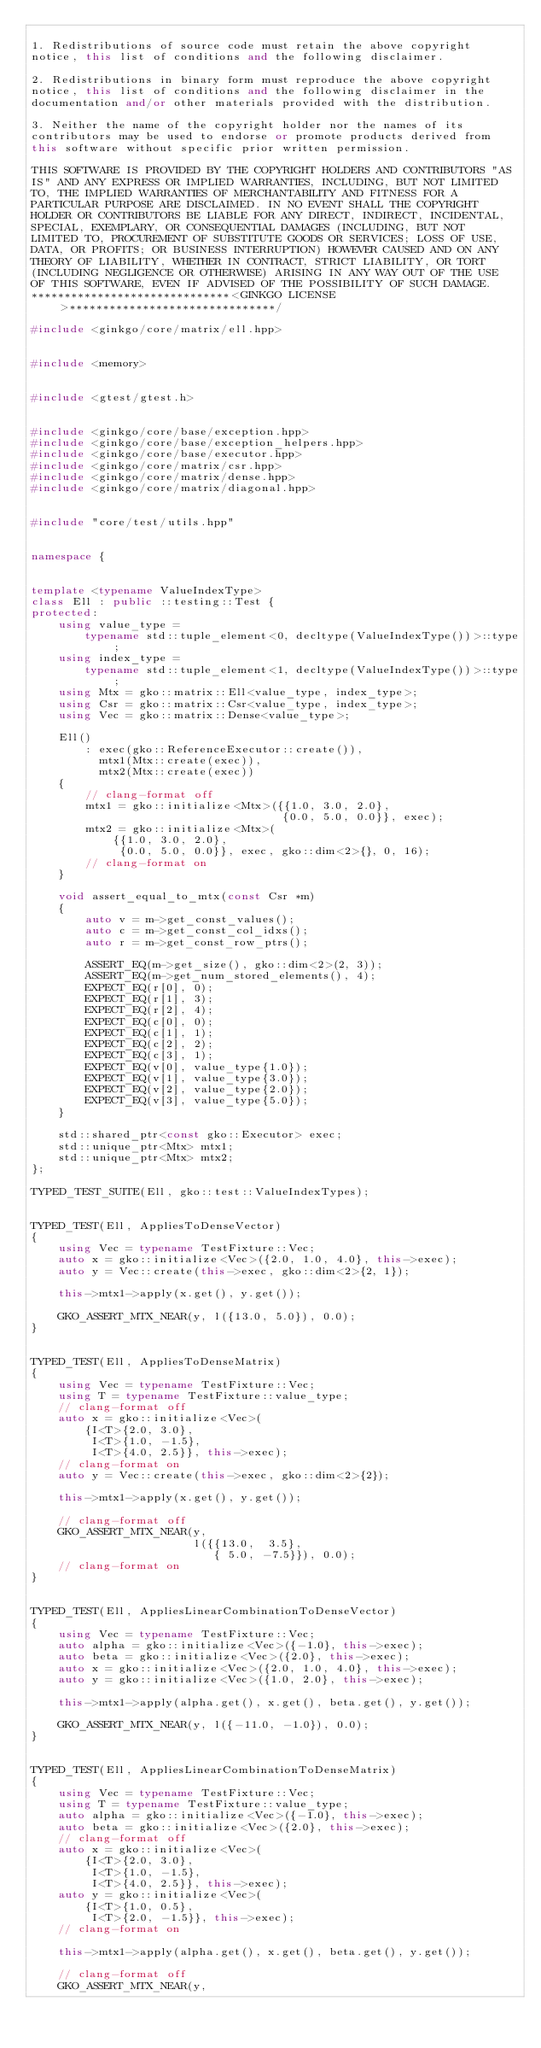<code> <loc_0><loc_0><loc_500><loc_500><_C++_>
1. Redistributions of source code must retain the above copyright
notice, this list of conditions and the following disclaimer.

2. Redistributions in binary form must reproduce the above copyright
notice, this list of conditions and the following disclaimer in the
documentation and/or other materials provided with the distribution.

3. Neither the name of the copyright holder nor the names of its
contributors may be used to endorse or promote products derived from
this software without specific prior written permission.

THIS SOFTWARE IS PROVIDED BY THE COPYRIGHT HOLDERS AND CONTRIBUTORS "AS
IS" AND ANY EXPRESS OR IMPLIED WARRANTIES, INCLUDING, BUT NOT LIMITED
TO, THE IMPLIED WARRANTIES OF MERCHANTABILITY AND FITNESS FOR A
PARTICULAR PURPOSE ARE DISCLAIMED. IN NO EVENT SHALL THE COPYRIGHT
HOLDER OR CONTRIBUTORS BE LIABLE FOR ANY DIRECT, INDIRECT, INCIDENTAL,
SPECIAL, EXEMPLARY, OR CONSEQUENTIAL DAMAGES (INCLUDING, BUT NOT
LIMITED TO, PROCUREMENT OF SUBSTITUTE GOODS OR SERVICES; LOSS OF USE,
DATA, OR PROFITS; OR BUSINESS INTERRUPTION) HOWEVER CAUSED AND ON ANY
THEORY OF LIABILITY, WHETHER IN CONTRACT, STRICT LIABILITY, OR TORT
(INCLUDING NEGLIGENCE OR OTHERWISE) ARISING IN ANY WAY OUT OF THE USE
OF THIS SOFTWARE, EVEN IF ADVISED OF THE POSSIBILITY OF SUCH DAMAGE.
******************************<GINKGO LICENSE>*******************************/

#include <ginkgo/core/matrix/ell.hpp>


#include <memory>


#include <gtest/gtest.h>


#include <ginkgo/core/base/exception.hpp>
#include <ginkgo/core/base/exception_helpers.hpp>
#include <ginkgo/core/base/executor.hpp>
#include <ginkgo/core/matrix/csr.hpp>
#include <ginkgo/core/matrix/dense.hpp>
#include <ginkgo/core/matrix/diagonal.hpp>


#include "core/test/utils.hpp"


namespace {


template <typename ValueIndexType>
class Ell : public ::testing::Test {
protected:
    using value_type =
        typename std::tuple_element<0, decltype(ValueIndexType())>::type;
    using index_type =
        typename std::tuple_element<1, decltype(ValueIndexType())>::type;
    using Mtx = gko::matrix::Ell<value_type, index_type>;
    using Csr = gko::matrix::Csr<value_type, index_type>;
    using Vec = gko::matrix::Dense<value_type>;

    Ell()
        : exec(gko::ReferenceExecutor::create()),
          mtx1(Mtx::create(exec)),
          mtx2(Mtx::create(exec))
    {
        // clang-format off
        mtx1 = gko::initialize<Mtx>({{1.0, 3.0, 2.0},
                                     {0.0, 5.0, 0.0}}, exec);
        mtx2 = gko::initialize<Mtx>(
            {{1.0, 3.0, 2.0},
             {0.0, 5.0, 0.0}}, exec, gko::dim<2>{}, 0, 16);
        // clang-format on
    }

    void assert_equal_to_mtx(const Csr *m)
    {
        auto v = m->get_const_values();
        auto c = m->get_const_col_idxs();
        auto r = m->get_const_row_ptrs();

        ASSERT_EQ(m->get_size(), gko::dim<2>(2, 3));
        ASSERT_EQ(m->get_num_stored_elements(), 4);
        EXPECT_EQ(r[0], 0);
        EXPECT_EQ(r[1], 3);
        EXPECT_EQ(r[2], 4);
        EXPECT_EQ(c[0], 0);
        EXPECT_EQ(c[1], 1);
        EXPECT_EQ(c[2], 2);
        EXPECT_EQ(c[3], 1);
        EXPECT_EQ(v[0], value_type{1.0});
        EXPECT_EQ(v[1], value_type{3.0});
        EXPECT_EQ(v[2], value_type{2.0});
        EXPECT_EQ(v[3], value_type{5.0});
    }

    std::shared_ptr<const gko::Executor> exec;
    std::unique_ptr<Mtx> mtx1;
    std::unique_ptr<Mtx> mtx2;
};

TYPED_TEST_SUITE(Ell, gko::test::ValueIndexTypes);


TYPED_TEST(Ell, AppliesToDenseVector)
{
    using Vec = typename TestFixture::Vec;
    auto x = gko::initialize<Vec>({2.0, 1.0, 4.0}, this->exec);
    auto y = Vec::create(this->exec, gko::dim<2>{2, 1});

    this->mtx1->apply(x.get(), y.get());

    GKO_ASSERT_MTX_NEAR(y, l({13.0, 5.0}), 0.0);
}


TYPED_TEST(Ell, AppliesToDenseMatrix)
{
    using Vec = typename TestFixture::Vec;
    using T = typename TestFixture::value_type;
    // clang-format off
    auto x = gko::initialize<Vec>(
        {I<T>{2.0, 3.0},
         I<T>{1.0, -1.5},
         I<T>{4.0, 2.5}}, this->exec);
    // clang-format on
    auto y = Vec::create(this->exec, gko::dim<2>{2});

    this->mtx1->apply(x.get(), y.get());

    // clang-format off
    GKO_ASSERT_MTX_NEAR(y,
                        l({{13.0,  3.5},
                           { 5.0, -7.5}}), 0.0);
    // clang-format on
}


TYPED_TEST(Ell, AppliesLinearCombinationToDenseVector)
{
    using Vec = typename TestFixture::Vec;
    auto alpha = gko::initialize<Vec>({-1.0}, this->exec);
    auto beta = gko::initialize<Vec>({2.0}, this->exec);
    auto x = gko::initialize<Vec>({2.0, 1.0, 4.0}, this->exec);
    auto y = gko::initialize<Vec>({1.0, 2.0}, this->exec);

    this->mtx1->apply(alpha.get(), x.get(), beta.get(), y.get());

    GKO_ASSERT_MTX_NEAR(y, l({-11.0, -1.0}), 0.0);
}


TYPED_TEST(Ell, AppliesLinearCombinationToDenseMatrix)
{
    using Vec = typename TestFixture::Vec;
    using T = typename TestFixture::value_type;
    auto alpha = gko::initialize<Vec>({-1.0}, this->exec);
    auto beta = gko::initialize<Vec>({2.0}, this->exec);
    // clang-format off
    auto x = gko::initialize<Vec>(
        {I<T>{2.0, 3.0},
         I<T>{1.0, -1.5},
         I<T>{4.0, 2.5}}, this->exec);
    auto y = gko::initialize<Vec>(
        {I<T>{1.0, 0.5},
         I<T>{2.0, -1.5}}, this->exec);
    // clang-format on

    this->mtx1->apply(alpha.get(), x.get(), beta.get(), y.get());

    // clang-format off
    GKO_ASSERT_MTX_NEAR(y,</code> 